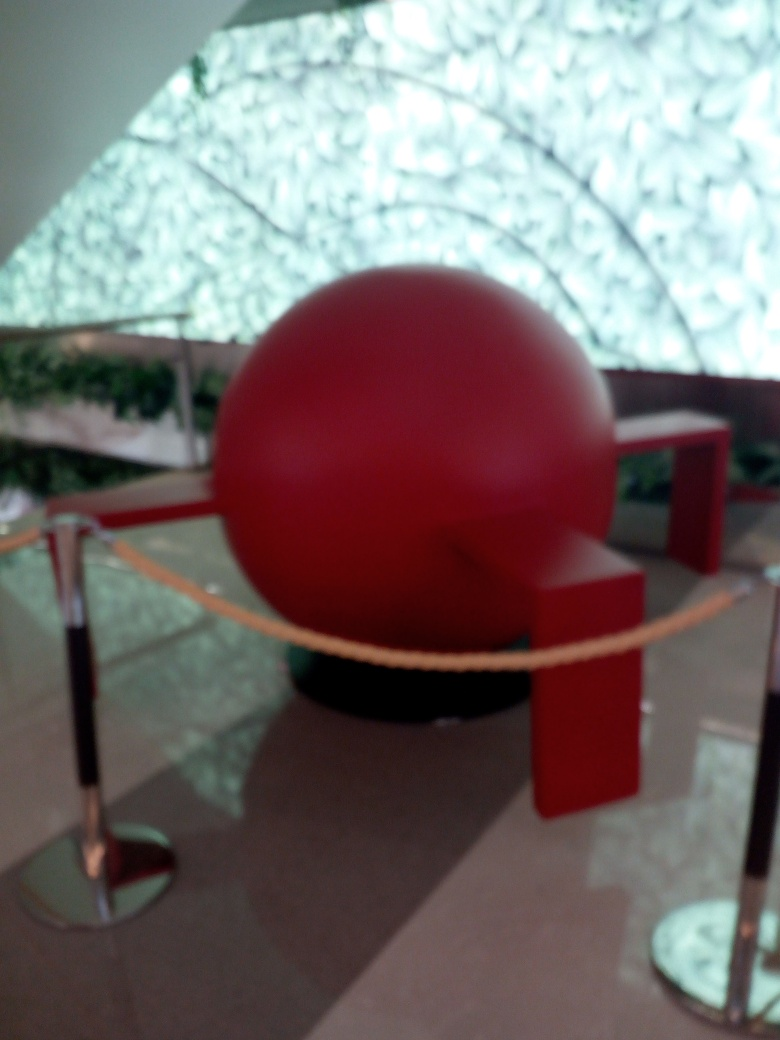Can you tell me more about the surrounding area? Although the image is blurry, you can discern a modern setting likely within an indoor space, possibly a gallery or public building. The ceiling seems to have a unique patterned design and natural light floods the space, indicating there might be skylights or large windows out of view. 